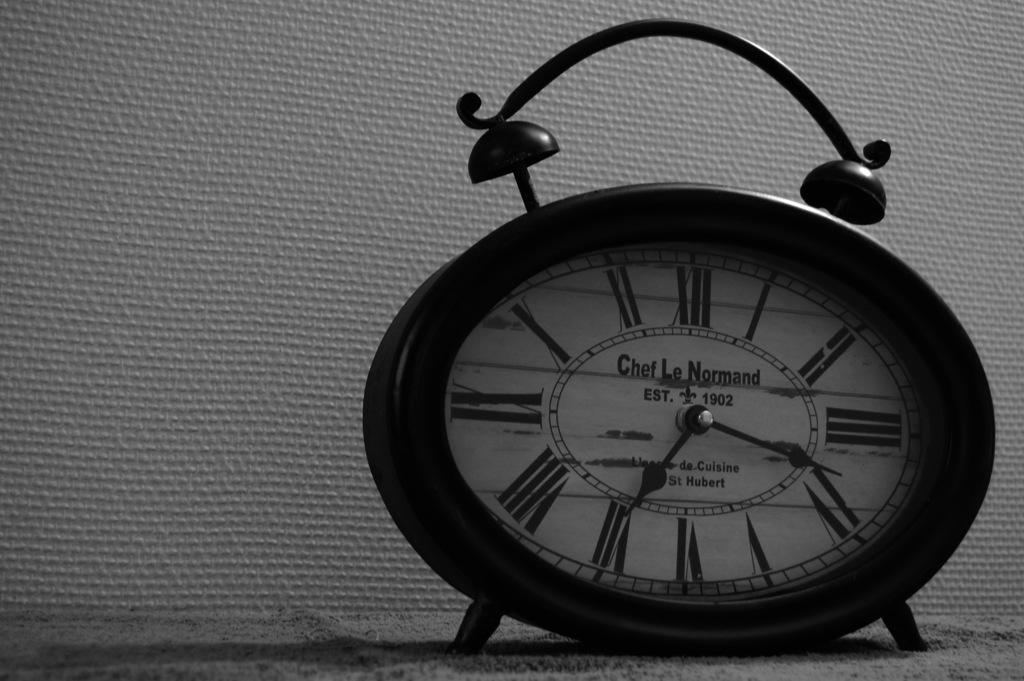<image>
Create a compact narrative representing the image presented. Chef Le Normand estb. 1902 by de-Cuisine St Hubert Alarm clock 